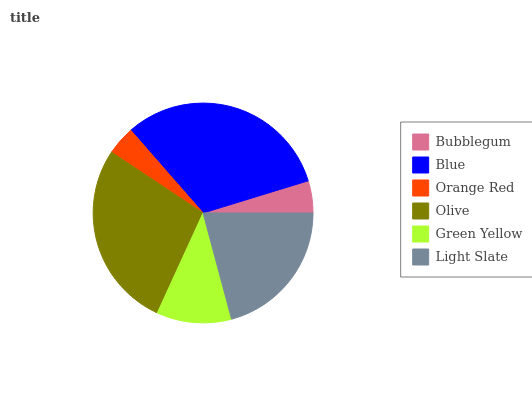Is Orange Red the minimum?
Answer yes or no. Yes. Is Blue the maximum?
Answer yes or no. Yes. Is Blue the minimum?
Answer yes or no. No. Is Orange Red the maximum?
Answer yes or no. No. Is Blue greater than Orange Red?
Answer yes or no. Yes. Is Orange Red less than Blue?
Answer yes or no. Yes. Is Orange Red greater than Blue?
Answer yes or no. No. Is Blue less than Orange Red?
Answer yes or no. No. Is Light Slate the high median?
Answer yes or no. Yes. Is Green Yellow the low median?
Answer yes or no. Yes. Is Orange Red the high median?
Answer yes or no. No. Is Olive the low median?
Answer yes or no. No. 